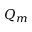Convert formula to latex. <formula><loc_0><loc_0><loc_500><loc_500>Q _ { m }</formula> 